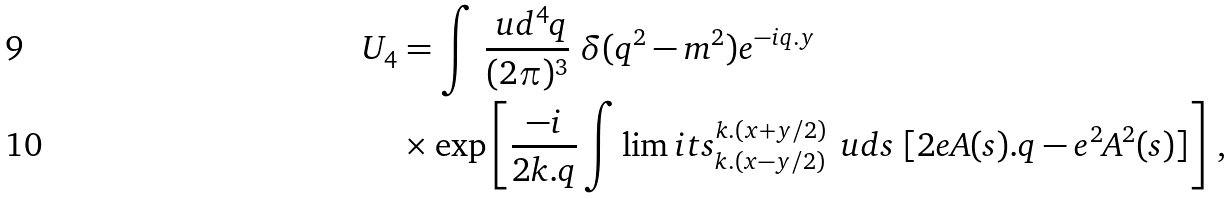Convert formula to latex. <formula><loc_0><loc_0><loc_500><loc_500>U _ { 4 } & = \int \, \frac { \ u d ^ { 4 } q } { ( 2 \pi ) ^ { 3 } } \ \delta ( q ^ { 2 } - m ^ { 2 } ) e ^ { - i q . y } \\ & \times \exp \left [ \frac { - i } { 2 k . q } \int \lim i t s _ { k . ( x - y / 2 ) } ^ { k . ( x + y / 2 ) } \, \ u d s \ [ 2 e A ( s ) . q - e ^ { 2 } A ^ { 2 } ( s ) ] \right ] \, ,</formula> 